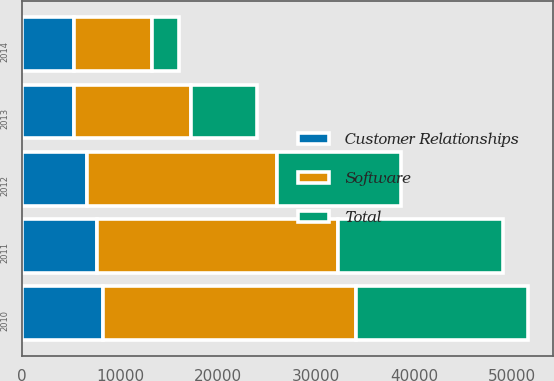Convert chart to OTSL. <chart><loc_0><loc_0><loc_500><loc_500><stacked_bar_chart><ecel><fcel>2010<fcel>2011<fcel>2012<fcel>2013<fcel>2014<nl><fcel>Customer Relationships<fcel>8236<fcel>7673<fcel>6647<fcel>5282<fcel>5282<nl><fcel>Total<fcel>17596<fcel>16876<fcel>12688<fcel>6690<fcel>2716<nl><fcel>Software<fcel>25832<fcel>24549<fcel>19335<fcel>11972<fcel>7998<nl></chart> 